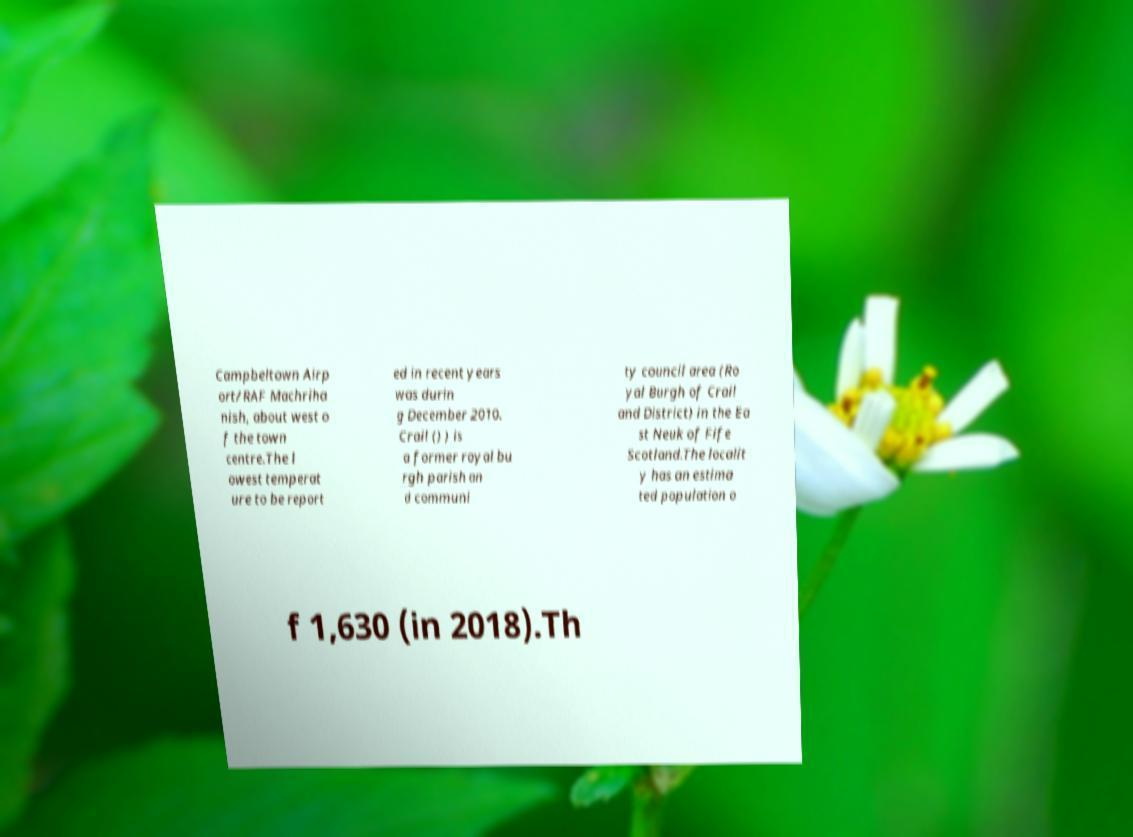What messages or text are displayed in this image? I need them in a readable, typed format. Campbeltown Airp ort/RAF Machriha nish, about west o f the town centre.The l owest temperat ure to be report ed in recent years was durin g December 2010. Crail () ) is a former royal bu rgh parish an d communi ty council area (Ro yal Burgh of Crail and District) in the Ea st Neuk of Fife Scotland.The localit y has an estima ted population o f 1,630 (in 2018).Th 